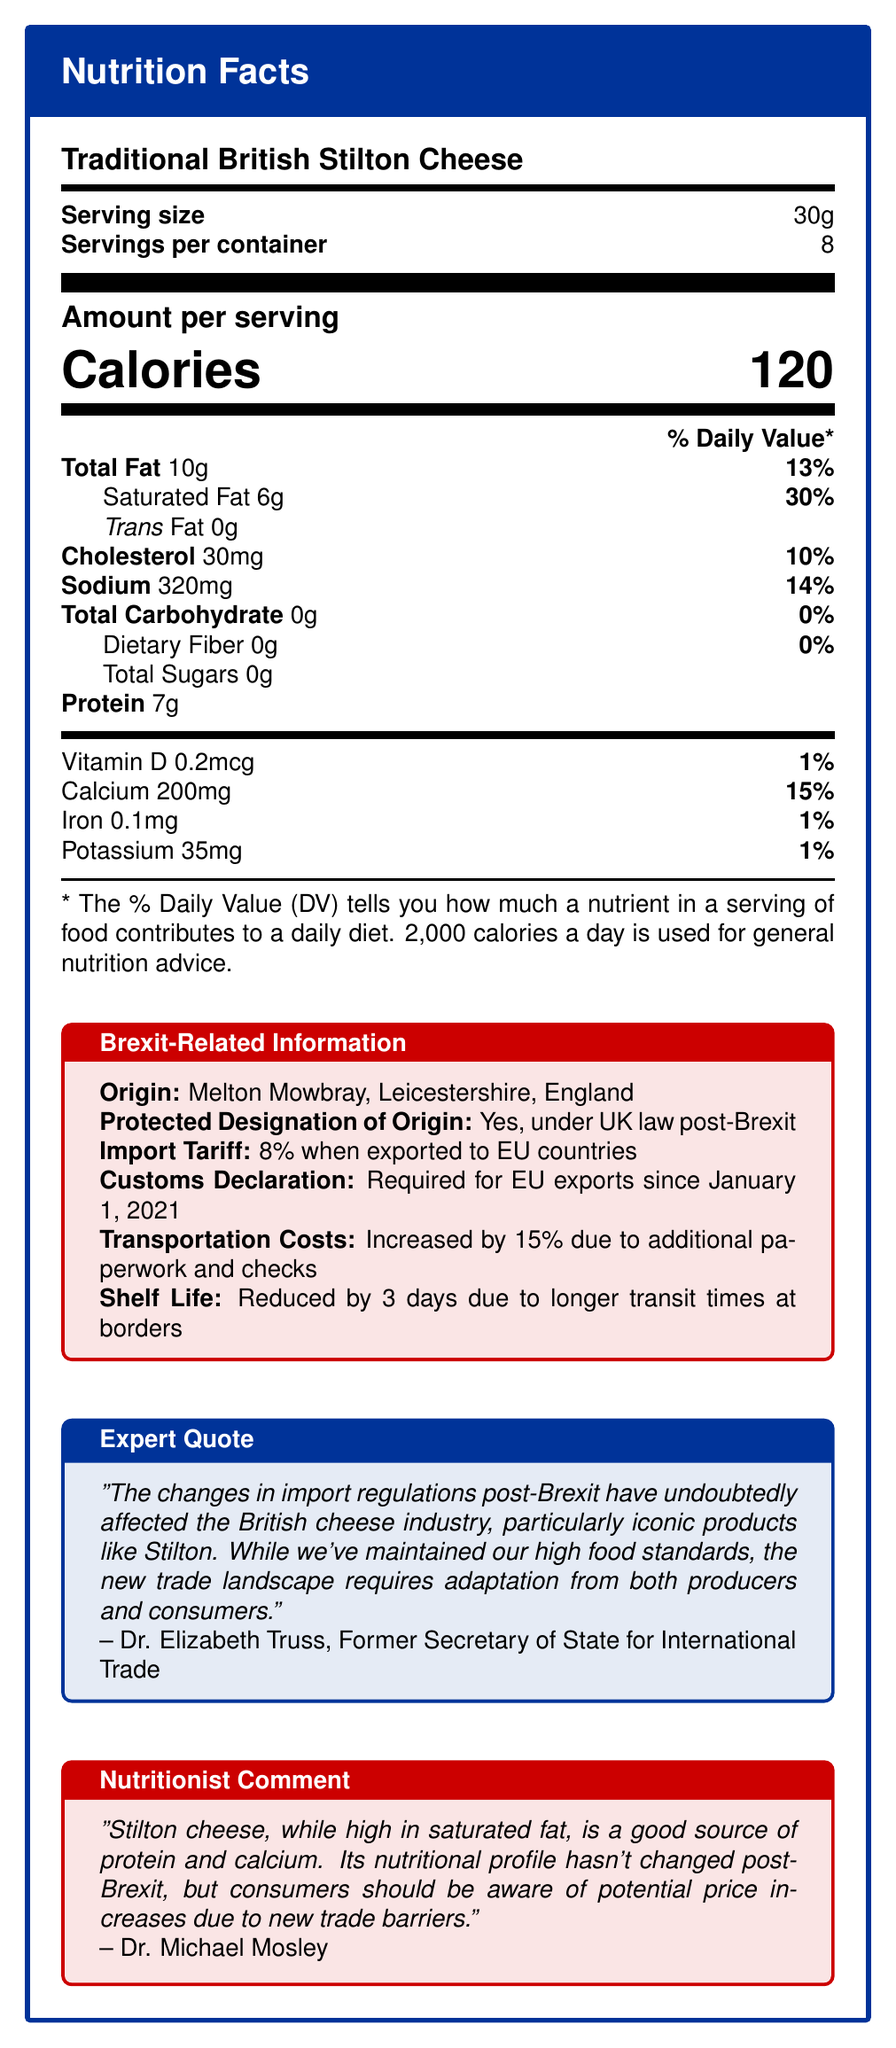what is the serving size for Traditional British Stilton Cheese? The serving size is clearly stated in the document as "Serving size: 30g".
Answer: 30g how many servings are there per container? The document specifies "Servings per container: 8".
Answer: 8 how much cholesterol is in one serving of Stilton Cheese? The document states "Cholesterol: 30mg".
Answer: 30mg What percentage of the Daily Value is saturated fat for a serving of Stilton Cheese? It is mentioned that saturated fat is 6g per serving, which represents 30% of the Daily Value.
Answer: 30% What is the origin of Traditional British Stilton Cheese? The Brexit-related information section indicates the origin as "Melton Mowbray, Leicestershire, England".
Answer: Melton Mowbray, Leicestershire, England which nutrient has the highest percentage of the Daily Value in a serving of Stilton Cheese? The document shows that saturated fat has the highest percentage at 30%.
Answer: Saturated Fat What is the protein content in a single serving of Stilton Cheese? The document specifies "Protein: 7g".
Answer: 7g what increased transportation cost affects Stilton Cheese due to Brexit? The Brexit-related information mentions "Transportation costs: Increased by 15% due to additional paperwork and checks".
Answer: 15% which of the following is required for exporting Stilton Cheese to the EU post-Brexit? 
A. Increased shelf life
B. Protected designation of origin
C. Customs declaration
D. No import tariff Option C is correct because the document mentions, "Customs Declaration: Required for EU exports since January 1, 2021".
Answer: C Which of the following statements is true about the shelf life of Stilton Cheese post-Brexit?
i. The shelf life has increased by 5 days.
ii. The shelf life is reduced by 3 days.
iii. The shelf life remains unchanged.
iv. The shelf life is reduced by 15%. The correct statement is ii. The Brexit-related information section states that the "Shelf Life: Reduced by 3 days due to longer transit times at borders".
Answer: ii. Has the nutritional profile of Stilton Cheese changed post-Brexit according to the nutritionist? Dr. Michael Mosley's comment states that "Its nutritional profile hasn't changed post-Brexit".
Answer: No Summarize the main idea of the document. The document is divided into sections providing detailed nutritional facts, Brexit-related impacts on Stilton Cheese, and expert opinions. The nutritional facts include serving size, calories, and daily values of several nutrients. Brexit-related information highlights changes such as import tariffs, customs requirements, transportation costs, and reduced shelf life. Additionally, there are expert comments on the broader implications of Brexit on the British cheese industry.
Answer: The document provides comprehensive nutritional information about Traditional British Stilton Cheese, including serving size, calories, and daily values of various nutrients. It also details the impact of Brexit on Stilton Cheese, such as origin, protected designation of origin, tariffs, customs declarations, increased transportation costs, reduced shelf life, and contains expert and nutritionist comments on the changes post-Brexit. Is there any information on vitamins other than Vitamin D in the document? The document only lists Vitamin D with a daily value of 1%, and there is no mention of other vitamins.
Answer: No What is the import tariff for Stilton Cheese when exported to EU countries post-Brexit? The Brexit-related information specifies an "Import Tariff: 8% when exported to EU countries".
Answer: 8% how has transit time affected Stilton Cheese shelf life due to Brexit? The document states that the shelf life is "Reduced by 3 days due to longer transit times at borders".
Answer: Reduced by 3 days Who provided the expert quote in the document? The expert quote is attributed to "Dr. Elizabeth Truss, Former Secretary of State for International Trade".
Answer: Dr. Elizabeth Truss Does the document mention the current price of Traditional British Stilton Cheese? The document does not provide any information regarding the current price of Stilton Cheese.
Answer: Cannot be determined 